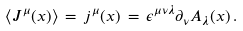<formula> <loc_0><loc_0><loc_500><loc_500>\langle J ^ { \mu } ( x ) \rangle \, = \, j ^ { \mu } ( x ) \, = \, \epsilon ^ { \mu \nu \lambda } \partial _ { \nu } A _ { \lambda } ( x ) \, .</formula> 